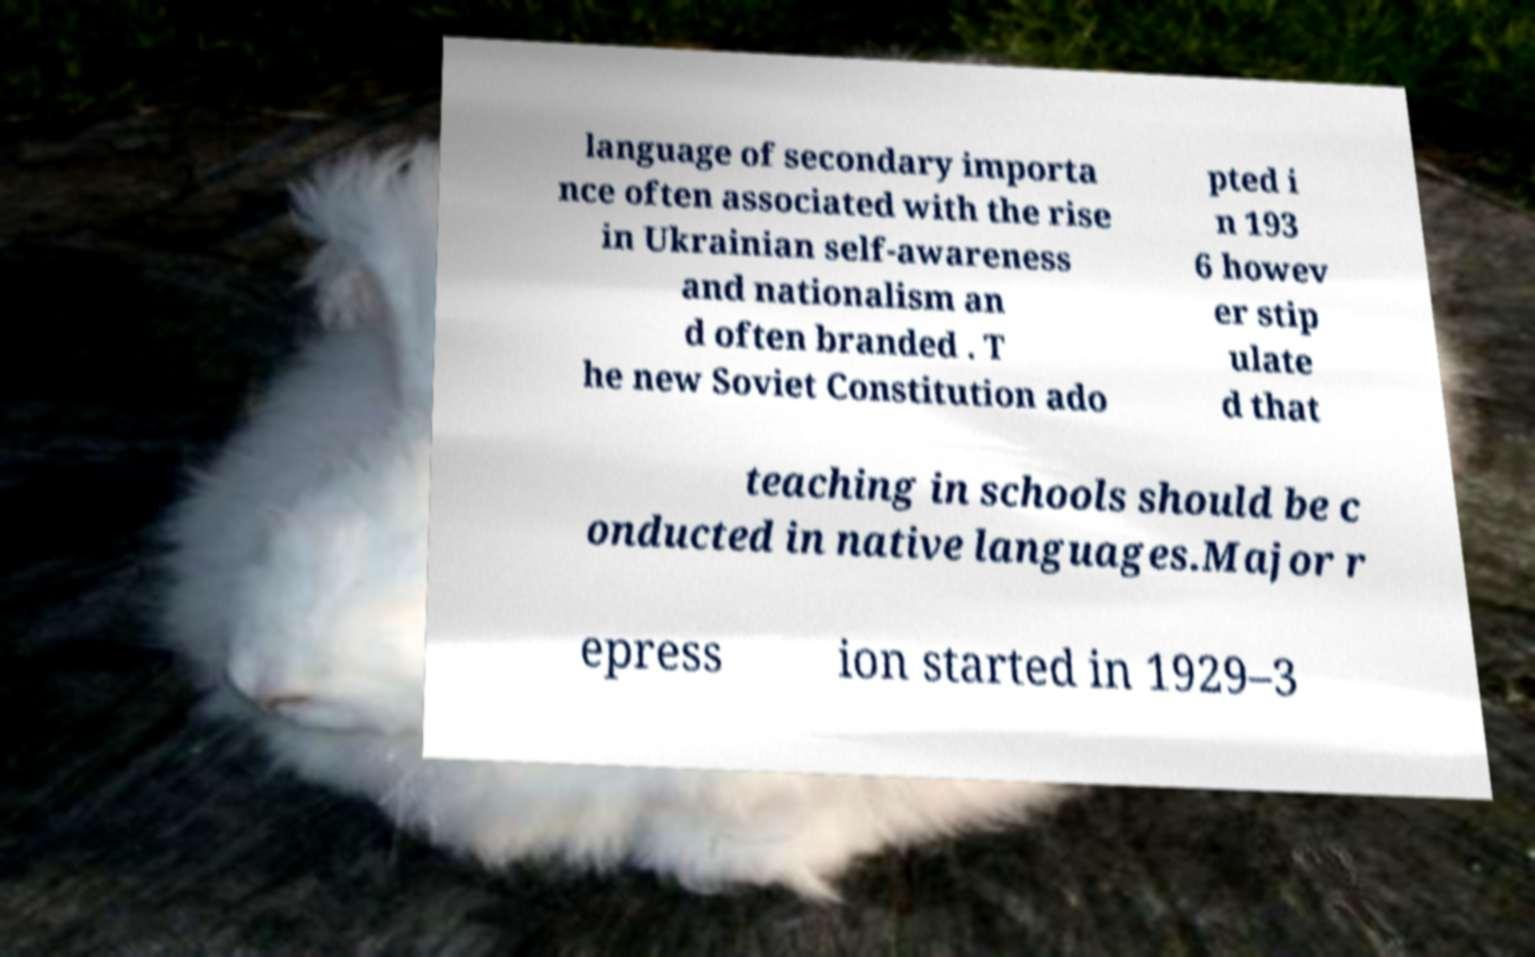What messages or text are displayed in this image? I need them in a readable, typed format. language of secondary importa nce often associated with the rise in Ukrainian self-awareness and nationalism an d often branded . T he new Soviet Constitution ado pted i n 193 6 howev er stip ulate d that teaching in schools should be c onducted in native languages.Major r epress ion started in 1929–3 